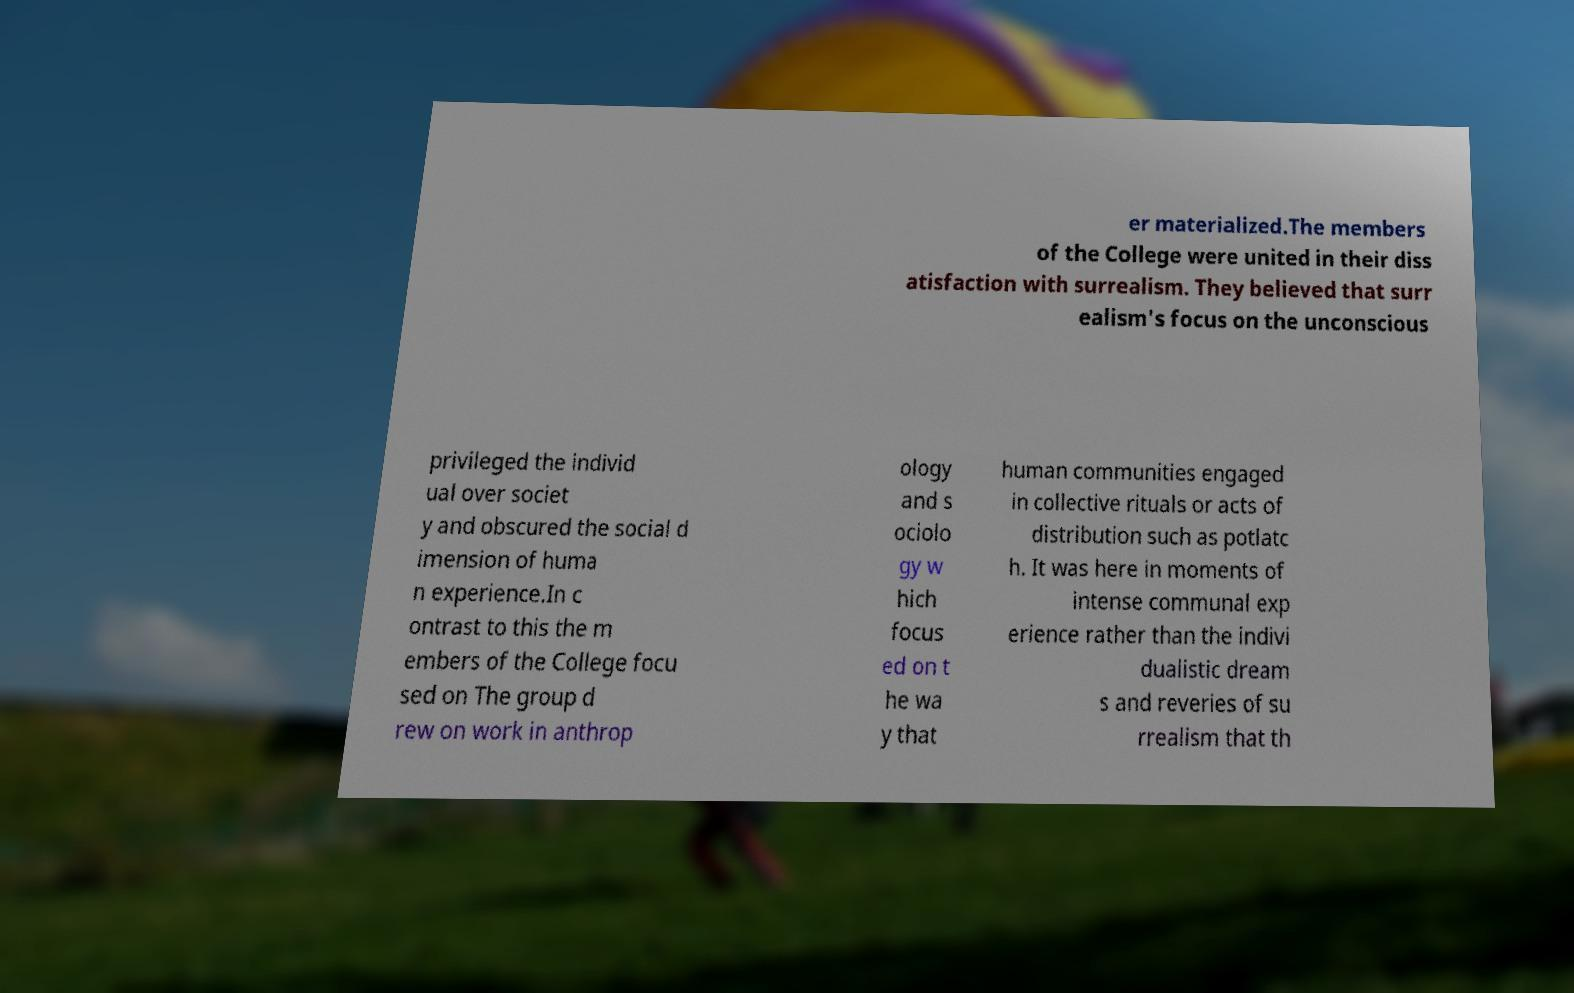There's text embedded in this image that I need extracted. Can you transcribe it verbatim? er materialized.The members of the College were united in their diss atisfaction with surrealism. They believed that surr ealism's focus on the unconscious privileged the individ ual over societ y and obscured the social d imension of huma n experience.In c ontrast to this the m embers of the College focu sed on The group d rew on work in anthrop ology and s ociolo gy w hich focus ed on t he wa y that human communities engaged in collective rituals or acts of distribution such as potlatc h. It was here in moments of intense communal exp erience rather than the indivi dualistic dream s and reveries of su rrealism that th 